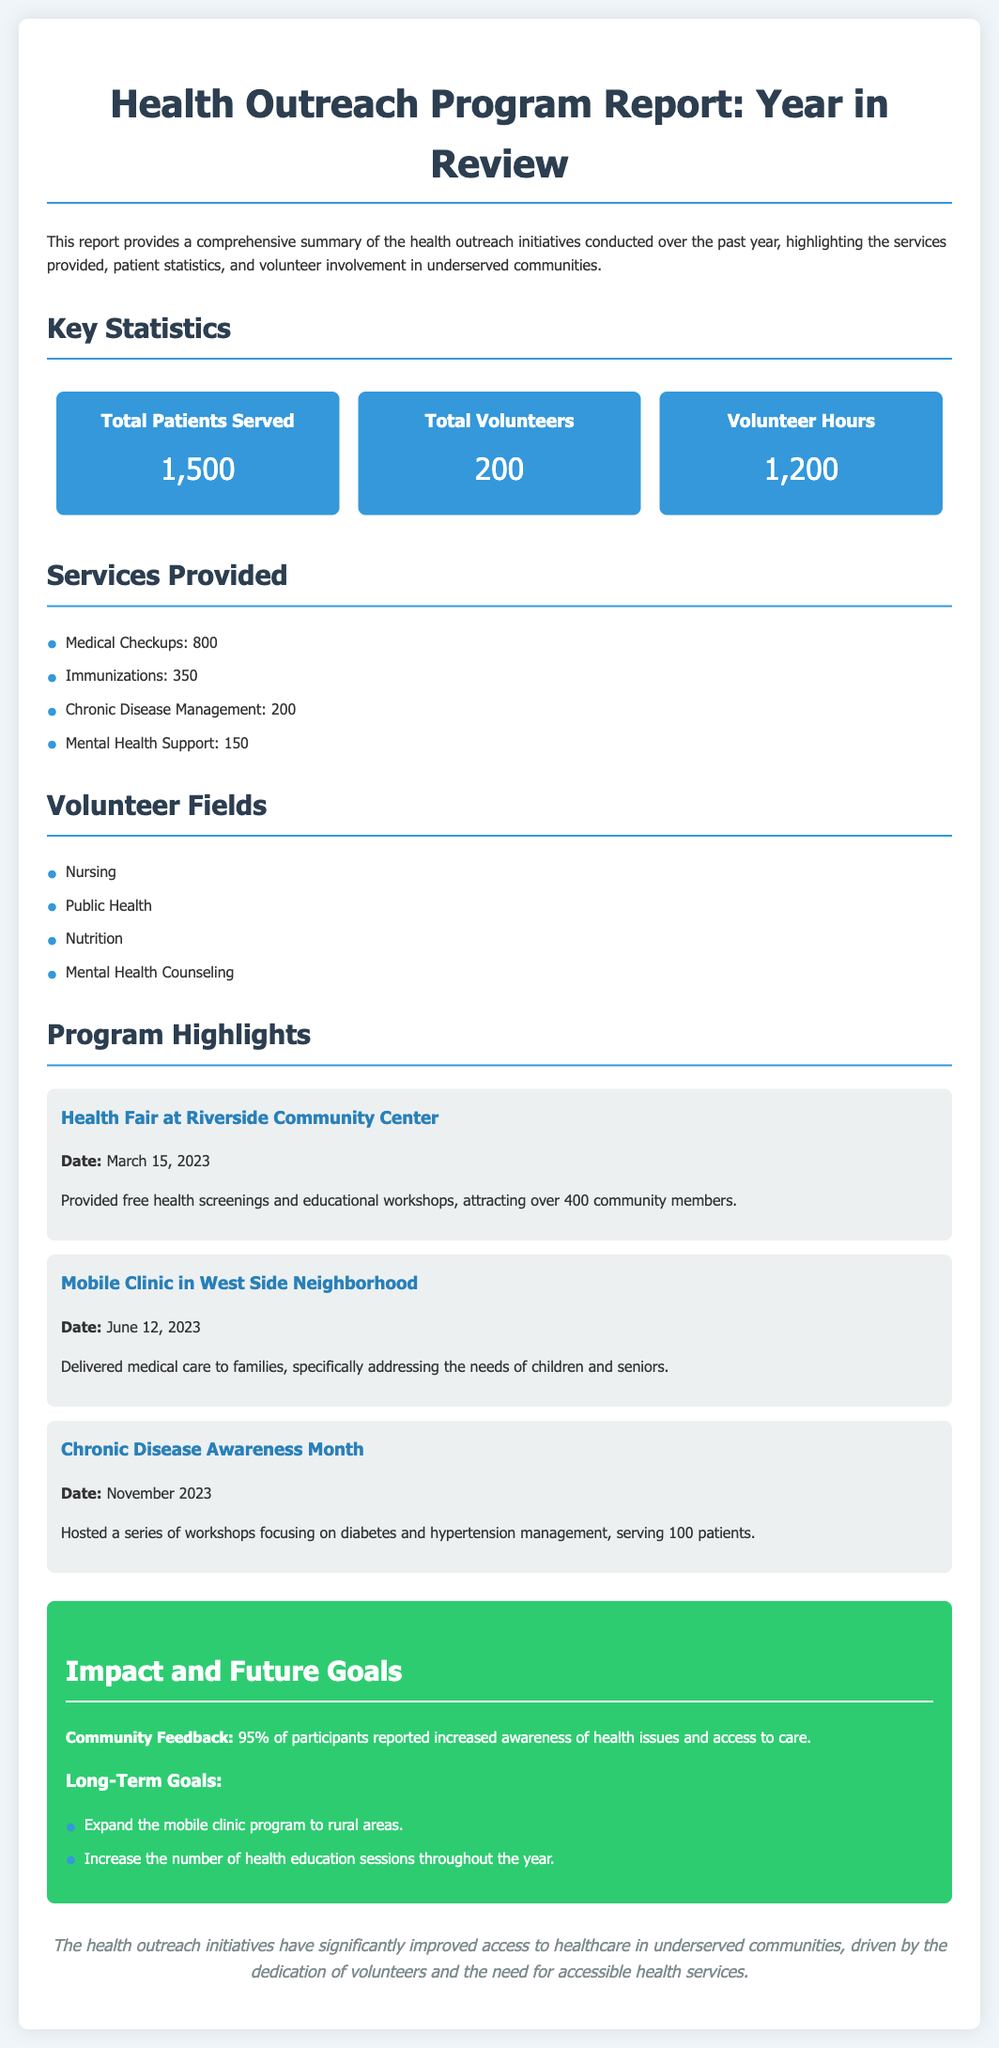What is the total number of patients served? The total number of patients served is stated directly in the key statistics section of the report.
Answer: 1,500 How many total volunteers participated? The report specifies the total number of volunteers in the key statistics section.
Answer: 200 What type of support was provided to patients the least? The services provided are listed in order of frequency, with the least number of support services offered being mental health support.
Answer: Mental Health Support What was the date of the Health Fair at Riverside Community Center? The specific date of the event is mentioned in the program highlights section.
Answer: March 15, 2023 How many hours did volunteers contribute? The total volunteer hours are provided in the statistical summary of the report.
Answer: 1,200 Which service provided was aimed at managing chronic diseases? Chronic disease management is one of the specific services mentioned in the report.
Answer: Chronic Disease Management What percentage of participants reported increased awareness of health issues? The document mentions feedback from participants regarding awareness, which is stated in percentage format.
Answer: 95% What are the long-term goals related to the mobile clinic? The goals regarding the mobile clinic are outlined specifically in the impact and future goals section.
Answer: Expand the mobile clinic program to rural areas Which service had the highest number of patients served? The service with the highest number is highlighted in the services provided section.
Answer: Medical Checkups 